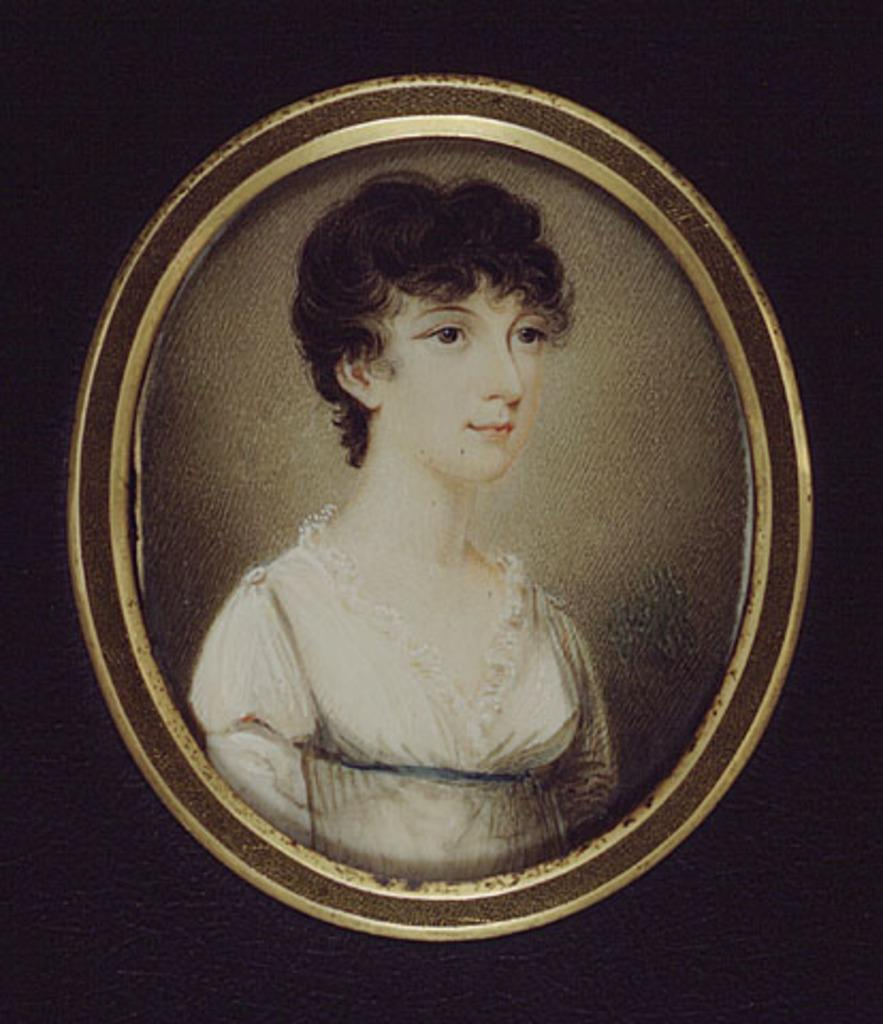What type of artwork is the image? The image is a painting. What subject is depicted in the painting? The painting depicts a lady. What type of seeds can be seen being traded in the painting? There are no seeds or trading activity depicted in the painting; it features a lady. What type of society is portrayed in the painting? The painting does not depict a specific society; it simply features a lady. 